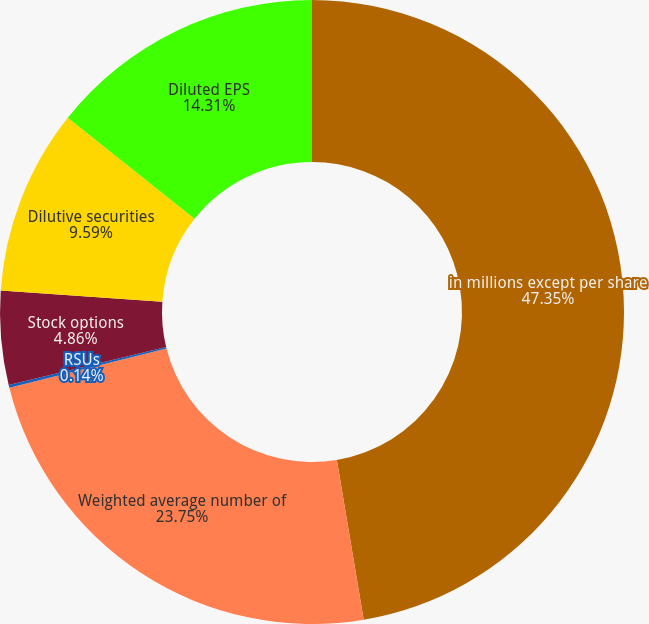Convert chart. <chart><loc_0><loc_0><loc_500><loc_500><pie_chart><fcel>in millions except per share<fcel>Weighted average number of<fcel>RSUs<fcel>Stock options<fcel>Dilutive securities<fcel>Diluted EPS<nl><fcel>47.35%<fcel>23.75%<fcel>0.14%<fcel>4.86%<fcel>9.59%<fcel>14.31%<nl></chart> 